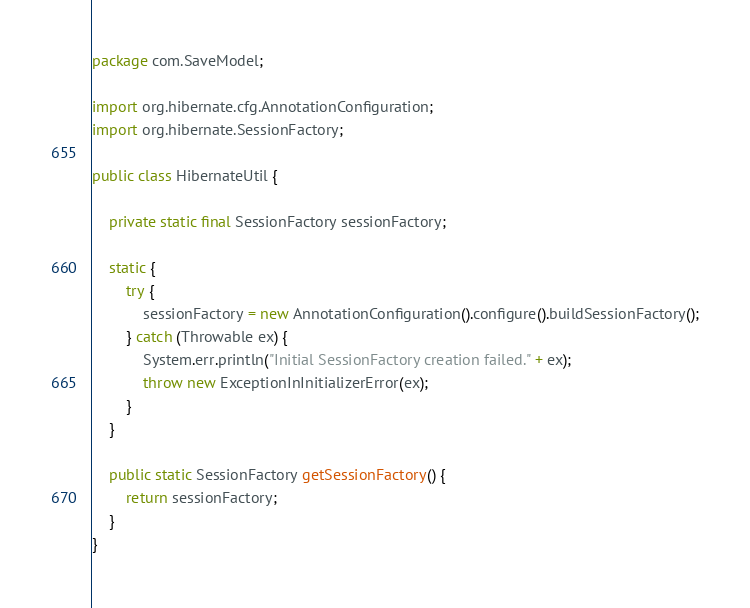<code> <loc_0><loc_0><loc_500><loc_500><_Java_>package com.SaveModel;

import org.hibernate.cfg.AnnotationConfiguration;
import org.hibernate.SessionFactory;

public class HibernateUtil {

    private static final SessionFactory sessionFactory;

    static {
        try {
            sessionFactory = new AnnotationConfiguration().configure().buildSessionFactory();
        } catch (Throwable ex) {
            System.err.println("Initial SessionFactory creation failed." + ex);
            throw new ExceptionInInitializerError(ex);
        }
    }

    public static SessionFactory getSessionFactory() {
        return sessionFactory;
    }
}
</code> 